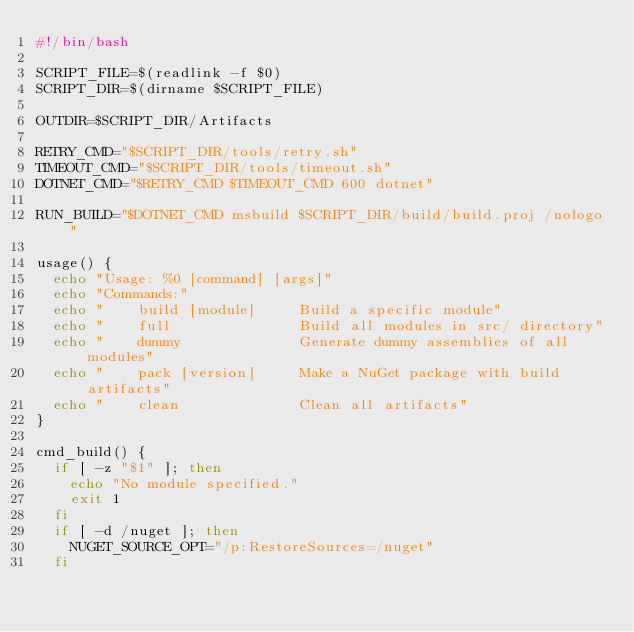Convert code to text. <code><loc_0><loc_0><loc_500><loc_500><_Bash_>#!/bin/bash

SCRIPT_FILE=$(readlink -f $0)
SCRIPT_DIR=$(dirname $SCRIPT_FILE)

OUTDIR=$SCRIPT_DIR/Artifacts

RETRY_CMD="$SCRIPT_DIR/tools/retry.sh"
TIMEOUT_CMD="$SCRIPT_DIR/tools/timeout.sh"
DOTNET_CMD="$RETRY_CMD $TIMEOUT_CMD 600 dotnet"

RUN_BUILD="$DOTNET_CMD msbuild $SCRIPT_DIR/build/build.proj /nologo"

usage() {
  echo "Usage: %0 [command] [args]"
  echo "Commands:"
  echo "    build [module]     Build a specific module"
  echo "    full               Build all modules in src/ directory"
  echo "    dummy              Generate dummy assemblies of all modules"
  echo "    pack [version]     Make a NuGet package with build artifacts"
  echo "    clean              Clean all artifacts"
}

cmd_build() {
  if [ -z "$1" ]; then
    echo "No module specified."
    exit 1
  fi
  if [ -d /nuget ]; then
    NUGET_SOURCE_OPT="/p:RestoreSources=/nuget"
  fi</code> 